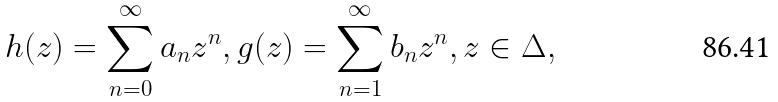<formula> <loc_0><loc_0><loc_500><loc_500>h ( z ) = \sum _ { n = 0 } ^ { \infty } a _ { n } z ^ { n } , g ( z ) = \sum _ { n = 1 } ^ { \infty } b _ { n } z ^ { n } , z \in \Delta ,</formula> 